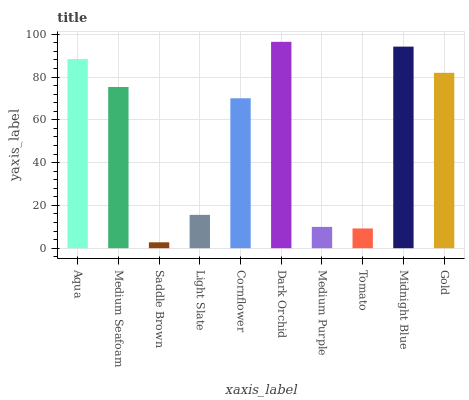Is Medium Seafoam the minimum?
Answer yes or no. No. Is Medium Seafoam the maximum?
Answer yes or no. No. Is Aqua greater than Medium Seafoam?
Answer yes or no. Yes. Is Medium Seafoam less than Aqua?
Answer yes or no. Yes. Is Medium Seafoam greater than Aqua?
Answer yes or no. No. Is Aqua less than Medium Seafoam?
Answer yes or no. No. Is Medium Seafoam the high median?
Answer yes or no. Yes. Is Cornflower the low median?
Answer yes or no. Yes. Is Dark Orchid the high median?
Answer yes or no. No. Is Light Slate the low median?
Answer yes or no. No. 